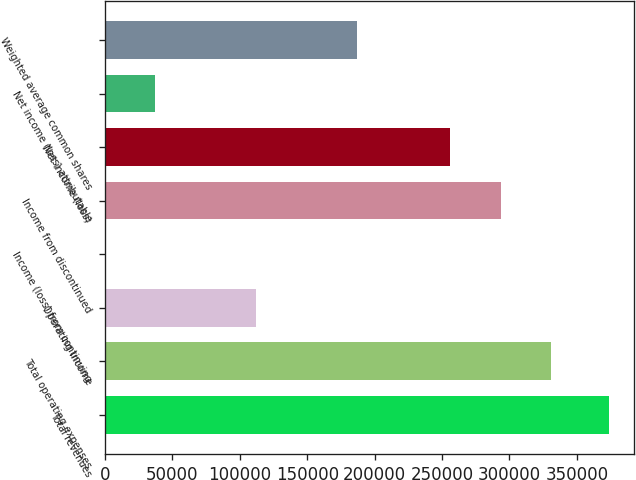<chart> <loc_0><loc_0><loc_500><loc_500><bar_chart><fcel>Total revenues<fcel>Total operating expenses<fcel>Operating income<fcel>Income (loss) from continuing<fcel>Income from discontinued<fcel>Net income (loss)<fcel>Net income (loss) attributable<fcel>Weighted average common shares<nl><fcel>374022<fcel>330843<fcel>112207<fcel>0.33<fcel>293441<fcel>256039<fcel>37402.5<fcel>187011<nl></chart> 